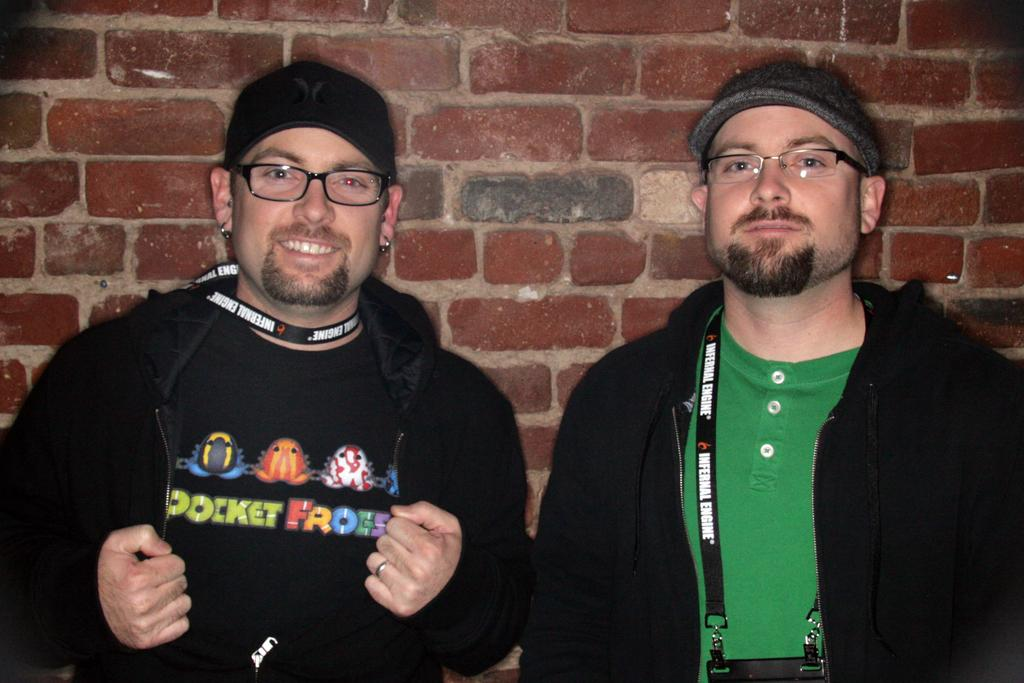How many people are in the image? There are two persons in the image. What do both persons have in common? Both persons are wearing glasses. Can you describe the expression of one of the persons? One of the persons is smiling. What can be seen in the background of the image? There is a brick wall in the background of the image. What type of thumb is being used to attack the person in the image? There is no thumb or attack present in the image; it features two persons wearing glasses, one of whom is smiling, and a brick wall in the background. 